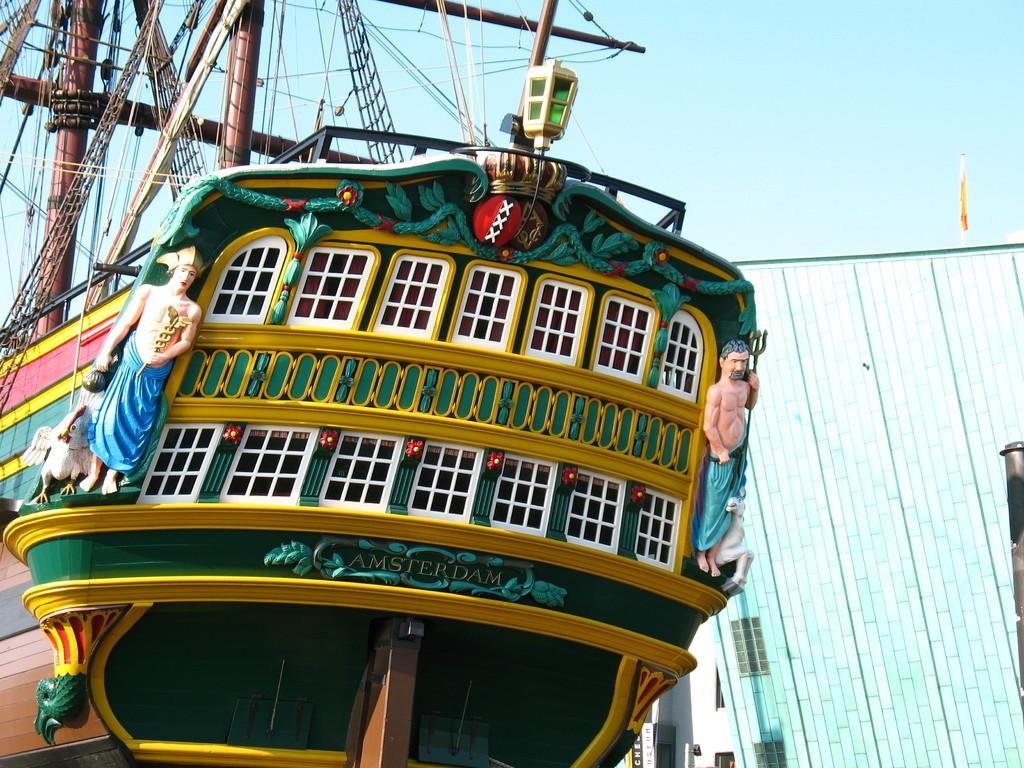Could you give a brief overview of what you see in this image? In this picture I can see a ship, building, and in the background there is the sky. 